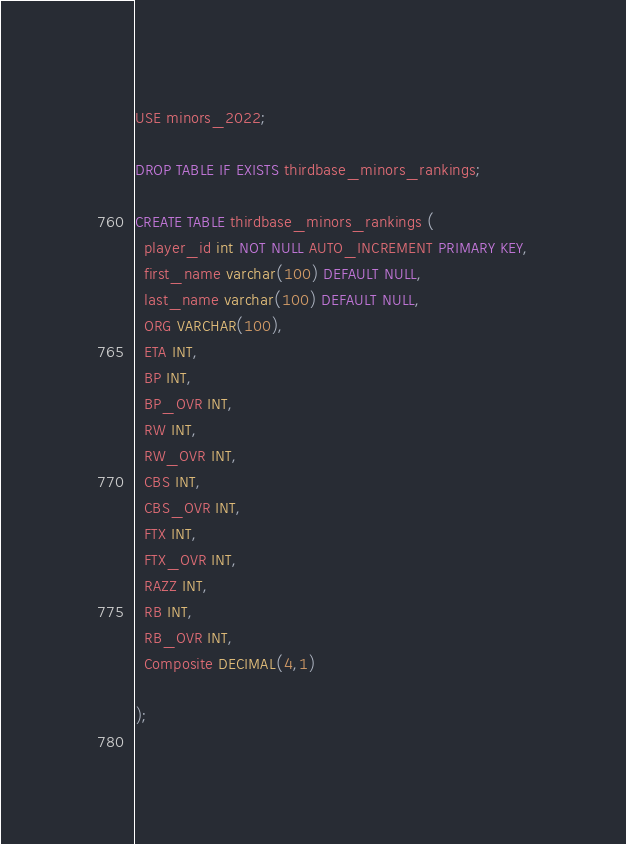Convert code to text. <code><loc_0><loc_0><loc_500><loc_500><_SQL_>USE minors_2022;

DROP TABLE IF EXISTS thirdbase_minors_rankings;

CREATE TABLE thirdbase_minors_rankings (
  player_id int NOT NULL AUTO_INCREMENT PRIMARY KEY,
  first_name varchar(100) DEFAULT NULL,
  last_name varchar(100) DEFAULT NULL,
  ORG VARCHAR(100),
  ETA INT,
  BP INT,
  BP_OVR INT,
  RW INT,
  RW_OVR INT,
  CBS INT,
  CBS_OVR INT,
  FTX INT,
  FTX_OVR INT,
  RAZZ INT,
  RB INT,
  RB_OVR INT,
  Composite DECIMAL(4,1)
  
);
  
</code> 